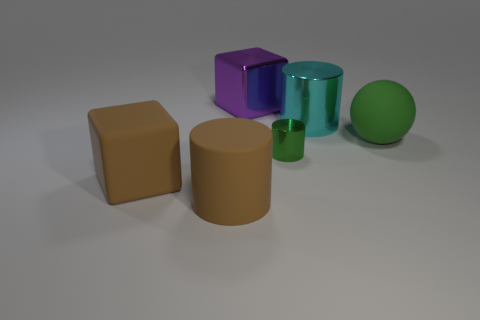Which objects in the image look like they have a reflective surface? The purple cube and the turquoise cylinder appear to have reflective surfaces, as indicated by the visible highlights and clear reflections on them. 